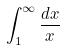<formula> <loc_0><loc_0><loc_500><loc_500>\int _ { 1 } ^ { \infty } \frac { d x } { x }</formula> 